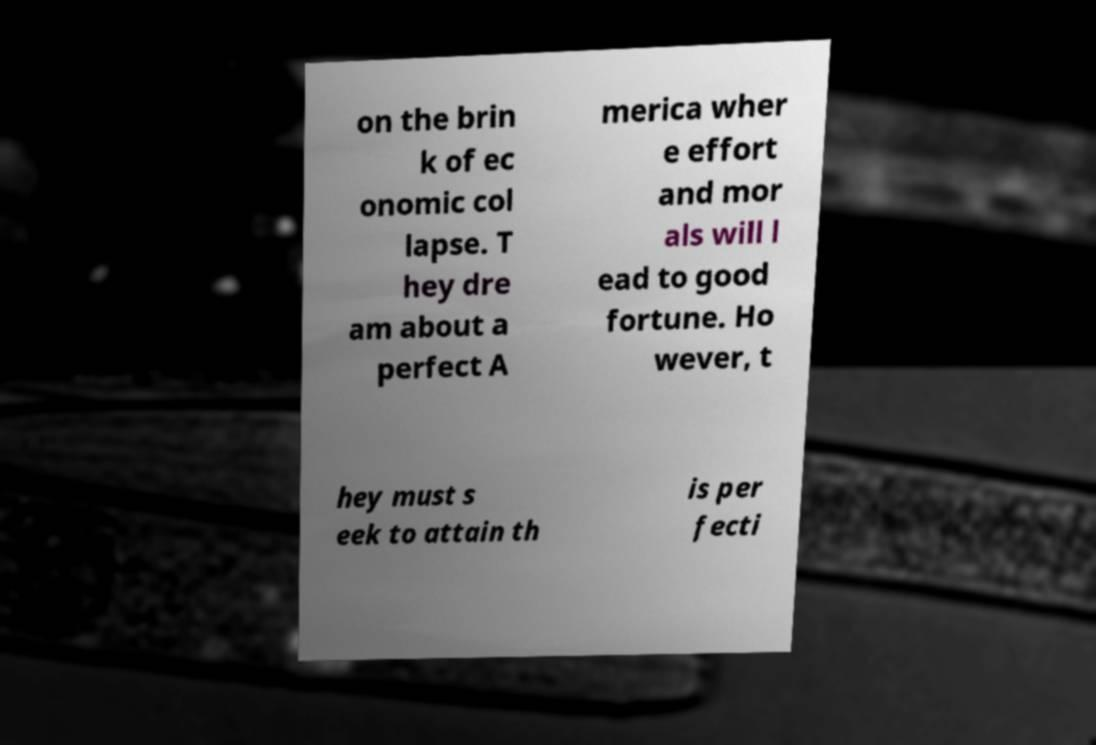What messages or text are displayed in this image? I need them in a readable, typed format. on the brin k of ec onomic col lapse. T hey dre am about a perfect A merica wher e effort and mor als will l ead to good fortune. Ho wever, t hey must s eek to attain th is per fecti 